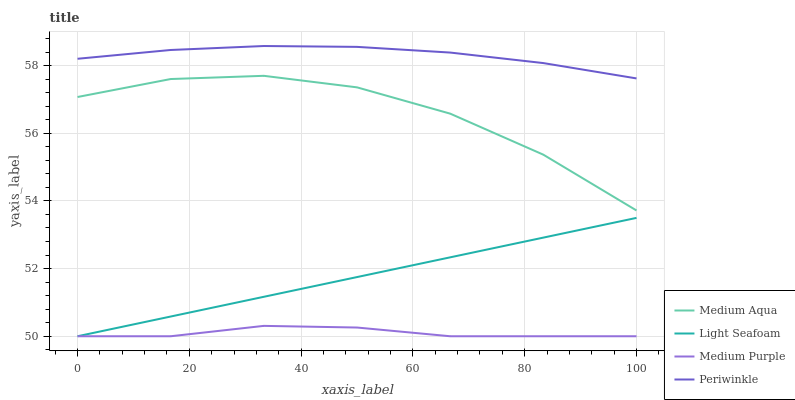Does Medium Purple have the minimum area under the curve?
Answer yes or no. Yes. Does Periwinkle have the maximum area under the curve?
Answer yes or no. Yes. Does Light Seafoam have the minimum area under the curve?
Answer yes or no. No. Does Light Seafoam have the maximum area under the curve?
Answer yes or no. No. Is Light Seafoam the smoothest?
Answer yes or no. Yes. Is Medium Aqua the roughest?
Answer yes or no. Yes. Is Periwinkle the smoothest?
Answer yes or no. No. Is Periwinkle the roughest?
Answer yes or no. No. Does Medium Purple have the lowest value?
Answer yes or no. Yes. Does Periwinkle have the lowest value?
Answer yes or no. No. Does Periwinkle have the highest value?
Answer yes or no. Yes. Does Light Seafoam have the highest value?
Answer yes or no. No. Is Medium Purple less than Medium Aqua?
Answer yes or no. Yes. Is Periwinkle greater than Medium Purple?
Answer yes or no. Yes. Does Medium Purple intersect Light Seafoam?
Answer yes or no. Yes. Is Medium Purple less than Light Seafoam?
Answer yes or no. No. Is Medium Purple greater than Light Seafoam?
Answer yes or no. No. Does Medium Purple intersect Medium Aqua?
Answer yes or no. No. 